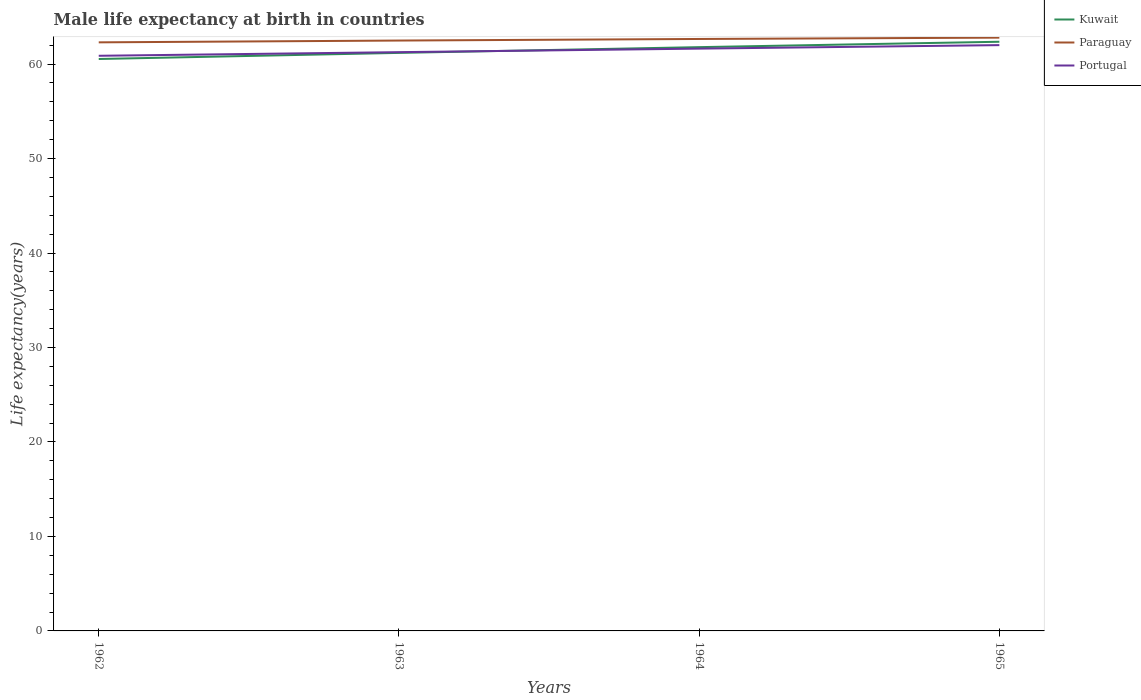Does the line corresponding to Kuwait intersect with the line corresponding to Portugal?
Offer a very short reply. Yes. Is the number of lines equal to the number of legend labels?
Offer a terse response. Yes. Across all years, what is the maximum male life expectancy at birth in Paraguay?
Offer a very short reply. 62.3. In which year was the male life expectancy at birth in Portugal maximum?
Offer a terse response. 1962. What is the total male life expectancy at birth in Kuwait in the graph?
Offer a terse response. -1.25. What is the difference between the highest and the second highest male life expectancy at birth in Kuwait?
Ensure brevity in your answer.  1.83. What is the difference between the highest and the lowest male life expectancy at birth in Kuwait?
Your answer should be compact. 2. Is the male life expectancy at birth in Portugal strictly greater than the male life expectancy at birth in Kuwait over the years?
Provide a succinct answer. No. How many years are there in the graph?
Provide a short and direct response. 4. What is the difference between two consecutive major ticks on the Y-axis?
Ensure brevity in your answer.  10. Does the graph contain grids?
Give a very brief answer. No. How many legend labels are there?
Make the answer very short. 3. How are the legend labels stacked?
Your answer should be compact. Vertical. What is the title of the graph?
Make the answer very short. Male life expectancy at birth in countries. What is the label or title of the Y-axis?
Offer a terse response. Life expectancy(years). What is the Life expectancy(years) of Kuwait in 1962?
Give a very brief answer. 60.54. What is the Life expectancy(years) in Paraguay in 1962?
Provide a succinct answer. 62.3. What is the Life expectancy(years) in Portugal in 1962?
Your answer should be very brief. 60.88. What is the Life expectancy(years) in Kuwait in 1963?
Keep it short and to the point. 61.19. What is the Life expectancy(years) in Paraguay in 1963?
Ensure brevity in your answer.  62.49. What is the Life expectancy(years) in Portugal in 1963?
Your response must be concise. 61.26. What is the Life expectancy(years) of Kuwait in 1964?
Give a very brief answer. 61.79. What is the Life expectancy(years) of Paraguay in 1964?
Offer a very short reply. 62.66. What is the Life expectancy(years) of Portugal in 1964?
Offer a terse response. 61.64. What is the Life expectancy(years) of Kuwait in 1965?
Offer a terse response. 62.37. What is the Life expectancy(years) in Paraguay in 1965?
Your answer should be very brief. 62.8. What is the Life expectancy(years) in Portugal in 1965?
Your response must be concise. 62.01. Across all years, what is the maximum Life expectancy(years) of Kuwait?
Provide a succinct answer. 62.37. Across all years, what is the maximum Life expectancy(years) in Paraguay?
Your answer should be compact. 62.8. Across all years, what is the maximum Life expectancy(years) in Portugal?
Make the answer very short. 62.01. Across all years, what is the minimum Life expectancy(years) in Kuwait?
Your response must be concise. 60.54. Across all years, what is the minimum Life expectancy(years) of Paraguay?
Ensure brevity in your answer.  62.3. Across all years, what is the minimum Life expectancy(years) in Portugal?
Provide a short and direct response. 60.88. What is the total Life expectancy(years) in Kuwait in the graph?
Make the answer very short. 245.88. What is the total Life expectancy(years) in Paraguay in the graph?
Your answer should be very brief. 250.25. What is the total Life expectancy(years) of Portugal in the graph?
Your answer should be compact. 245.79. What is the difference between the Life expectancy(years) of Kuwait in 1962 and that in 1963?
Offer a terse response. -0.65. What is the difference between the Life expectancy(years) of Paraguay in 1962 and that in 1963?
Give a very brief answer. -0.19. What is the difference between the Life expectancy(years) of Portugal in 1962 and that in 1963?
Keep it short and to the point. -0.38. What is the difference between the Life expectancy(years) of Kuwait in 1962 and that in 1964?
Provide a short and direct response. -1.25. What is the difference between the Life expectancy(years) of Paraguay in 1962 and that in 1964?
Ensure brevity in your answer.  -0.36. What is the difference between the Life expectancy(years) of Portugal in 1962 and that in 1964?
Keep it short and to the point. -0.76. What is the difference between the Life expectancy(years) in Kuwait in 1962 and that in 1965?
Give a very brief answer. -1.82. What is the difference between the Life expectancy(years) in Paraguay in 1962 and that in 1965?
Keep it short and to the point. -0.5. What is the difference between the Life expectancy(years) of Portugal in 1962 and that in 1965?
Keep it short and to the point. -1.13. What is the difference between the Life expectancy(years) in Kuwait in 1963 and that in 1964?
Offer a very short reply. -0.61. What is the difference between the Life expectancy(years) of Paraguay in 1963 and that in 1964?
Your answer should be very brief. -0.17. What is the difference between the Life expectancy(years) in Portugal in 1963 and that in 1964?
Offer a terse response. -0.37. What is the difference between the Life expectancy(years) in Kuwait in 1963 and that in 1965?
Your response must be concise. -1.18. What is the difference between the Life expectancy(years) in Paraguay in 1963 and that in 1965?
Offer a very short reply. -0.31. What is the difference between the Life expectancy(years) in Portugal in 1963 and that in 1965?
Give a very brief answer. -0.74. What is the difference between the Life expectancy(years) in Kuwait in 1964 and that in 1965?
Your answer should be compact. -0.57. What is the difference between the Life expectancy(years) in Paraguay in 1964 and that in 1965?
Make the answer very short. -0.14. What is the difference between the Life expectancy(years) in Portugal in 1964 and that in 1965?
Provide a succinct answer. -0.37. What is the difference between the Life expectancy(years) in Kuwait in 1962 and the Life expectancy(years) in Paraguay in 1963?
Give a very brief answer. -1.95. What is the difference between the Life expectancy(years) in Kuwait in 1962 and the Life expectancy(years) in Portugal in 1963?
Offer a very short reply. -0.72. What is the difference between the Life expectancy(years) in Paraguay in 1962 and the Life expectancy(years) in Portugal in 1963?
Ensure brevity in your answer.  1.04. What is the difference between the Life expectancy(years) in Kuwait in 1962 and the Life expectancy(years) in Paraguay in 1964?
Your answer should be compact. -2.12. What is the difference between the Life expectancy(years) of Kuwait in 1962 and the Life expectancy(years) of Portugal in 1964?
Provide a short and direct response. -1.1. What is the difference between the Life expectancy(years) in Paraguay in 1962 and the Life expectancy(years) in Portugal in 1964?
Give a very brief answer. 0.67. What is the difference between the Life expectancy(years) in Kuwait in 1962 and the Life expectancy(years) in Paraguay in 1965?
Provide a short and direct response. -2.26. What is the difference between the Life expectancy(years) in Kuwait in 1962 and the Life expectancy(years) in Portugal in 1965?
Offer a terse response. -1.47. What is the difference between the Life expectancy(years) of Paraguay in 1962 and the Life expectancy(years) of Portugal in 1965?
Offer a very short reply. 0.29. What is the difference between the Life expectancy(years) of Kuwait in 1963 and the Life expectancy(years) of Paraguay in 1964?
Your answer should be very brief. -1.47. What is the difference between the Life expectancy(years) in Kuwait in 1963 and the Life expectancy(years) in Portugal in 1964?
Offer a very short reply. -0.45. What is the difference between the Life expectancy(years) in Paraguay in 1963 and the Life expectancy(years) in Portugal in 1964?
Make the answer very short. 0.85. What is the difference between the Life expectancy(years) of Kuwait in 1963 and the Life expectancy(years) of Paraguay in 1965?
Your response must be concise. -1.61. What is the difference between the Life expectancy(years) of Kuwait in 1963 and the Life expectancy(years) of Portugal in 1965?
Your answer should be compact. -0.82. What is the difference between the Life expectancy(years) in Paraguay in 1963 and the Life expectancy(years) in Portugal in 1965?
Your answer should be compact. 0.48. What is the difference between the Life expectancy(years) of Kuwait in 1964 and the Life expectancy(years) of Paraguay in 1965?
Your answer should be compact. -1.01. What is the difference between the Life expectancy(years) of Kuwait in 1964 and the Life expectancy(years) of Portugal in 1965?
Ensure brevity in your answer.  -0.21. What is the difference between the Life expectancy(years) in Paraguay in 1964 and the Life expectancy(years) in Portugal in 1965?
Make the answer very short. 0.65. What is the average Life expectancy(years) in Kuwait per year?
Provide a short and direct response. 61.47. What is the average Life expectancy(years) in Paraguay per year?
Provide a succinct answer. 62.56. What is the average Life expectancy(years) in Portugal per year?
Offer a very short reply. 61.45. In the year 1962, what is the difference between the Life expectancy(years) of Kuwait and Life expectancy(years) of Paraguay?
Your response must be concise. -1.76. In the year 1962, what is the difference between the Life expectancy(years) in Kuwait and Life expectancy(years) in Portugal?
Your answer should be compact. -0.34. In the year 1962, what is the difference between the Life expectancy(years) of Paraguay and Life expectancy(years) of Portugal?
Your answer should be very brief. 1.42. In the year 1963, what is the difference between the Life expectancy(years) of Kuwait and Life expectancy(years) of Paraguay?
Make the answer very short. -1.31. In the year 1963, what is the difference between the Life expectancy(years) in Kuwait and Life expectancy(years) in Portugal?
Your answer should be compact. -0.08. In the year 1963, what is the difference between the Life expectancy(years) in Paraguay and Life expectancy(years) in Portugal?
Ensure brevity in your answer.  1.23. In the year 1964, what is the difference between the Life expectancy(years) of Kuwait and Life expectancy(years) of Paraguay?
Offer a terse response. -0.86. In the year 1964, what is the difference between the Life expectancy(years) in Kuwait and Life expectancy(years) in Portugal?
Your answer should be very brief. 0.16. In the year 1965, what is the difference between the Life expectancy(years) in Kuwait and Life expectancy(years) in Paraguay?
Offer a terse response. -0.43. In the year 1965, what is the difference between the Life expectancy(years) of Kuwait and Life expectancy(years) of Portugal?
Your answer should be very brief. 0.36. In the year 1965, what is the difference between the Life expectancy(years) in Paraguay and Life expectancy(years) in Portugal?
Your answer should be compact. 0.79. What is the ratio of the Life expectancy(years) in Portugal in 1962 to that in 1963?
Your response must be concise. 0.99. What is the ratio of the Life expectancy(years) in Kuwait in 1962 to that in 1964?
Provide a short and direct response. 0.98. What is the ratio of the Life expectancy(years) in Paraguay in 1962 to that in 1964?
Your answer should be compact. 0.99. What is the ratio of the Life expectancy(years) in Kuwait in 1962 to that in 1965?
Your response must be concise. 0.97. What is the ratio of the Life expectancy(years) in Portugal in 1962 to that in 1965?
Provide a short and direct response. 0.98. What is the ratio of the Life expectancy(years) in Kuwait in 1963 to that in 1964?
Your answer should be compact. 0.99. What is the ratio of the Life expectancy(years) of Paraguay in 1963 to that in 1964?
Your answer should be compact. 1. What is the ratio of the Life expectancy(years) in Kuwait in 1963 to that in 1965?
Your answer should be very brief. 0.98. What is the ratio of the Life expectancy(years) in Paraguay in 1963 to that in 1965?
Your answer should be compact. 1. What is the ratio of the Life expectancy(years) in Portugal in 1963 to that in 1965?
Give a very brief answer. 0.99. What is the ratio of the Life expectancy(years) in Kuwait in 1964 to that in 1965?
Give a very brief answer. 0.99. What is the ratio of the Life expectancy(years) in Portugal in 1964 to that in 1965?
Your answer should be very brief. 0.99. What is the difference between the highest and the second highest Life expectancy(years) in Kuwait?
Make the answer very short. 0.57. What is the difference between the highest and the second highest Life expectancy(years) of Paraguay?
Provide a succinct answer. 0.14. What is the difference between the highest and the second highest Life expectancy(years) in Portugal?
Offer a very short reply. 0.37. What is the difference between the highest and the lowest Life expectancy(years) in Kuwait?
Your answer should be compact. 1.82. What is the difference between the highest and the lowest Life expectancy(years) of Paraguay?
Your answer should be compact. 0.5. What is the difference between the highest and the lowest Life expectancy(years) of Portugal?
Give a very brief answer. 1.13. 